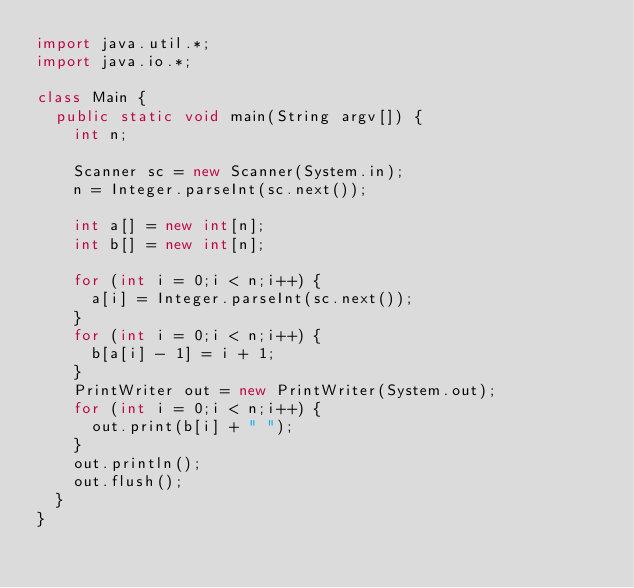<code> <loc_0><loc_0><loc_500><loc_500><_Java_>import java.util.*;
import java.io.*;

class Main {
  public static void main(String argv[]) {
    int n;
    
    Scanner sc = new Scanner(System.in);
    n = Integer.parseInt(sc.next());
    
    int a[] = new int[n];
    int b[] = new int[n];
    
    for (int i = 0;i < n;i++) {
      a[i] = Integer.parseInt(sc.next());
    }
    for (int i = 0;i < n;i++) {
      b[a[i] - 1] = i + 1;
    }
    PrintWriter out = new PrintWriter(System.out);
    for (int i = 0;i < n;i++) {
      out.print(b[i] + " ");
    }
    out.println();
    out.flush();
  }
}</code> 